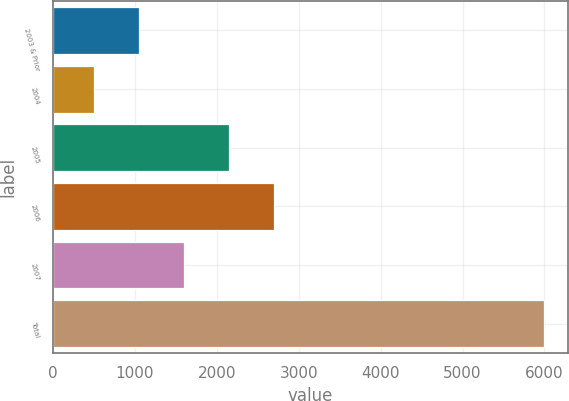<chart> <loc_0><loc_0><loc_500><loc_500><bar_chart><fcel>2003 & Prior<fcel>2004<fcel>2005<fcel>2006<fcel>2007<fcel>Total<nl><fcel>1051<fcel>502<fcel>2149<fcel>2698<fcel>1600<fcel>5992<nl></chart> 